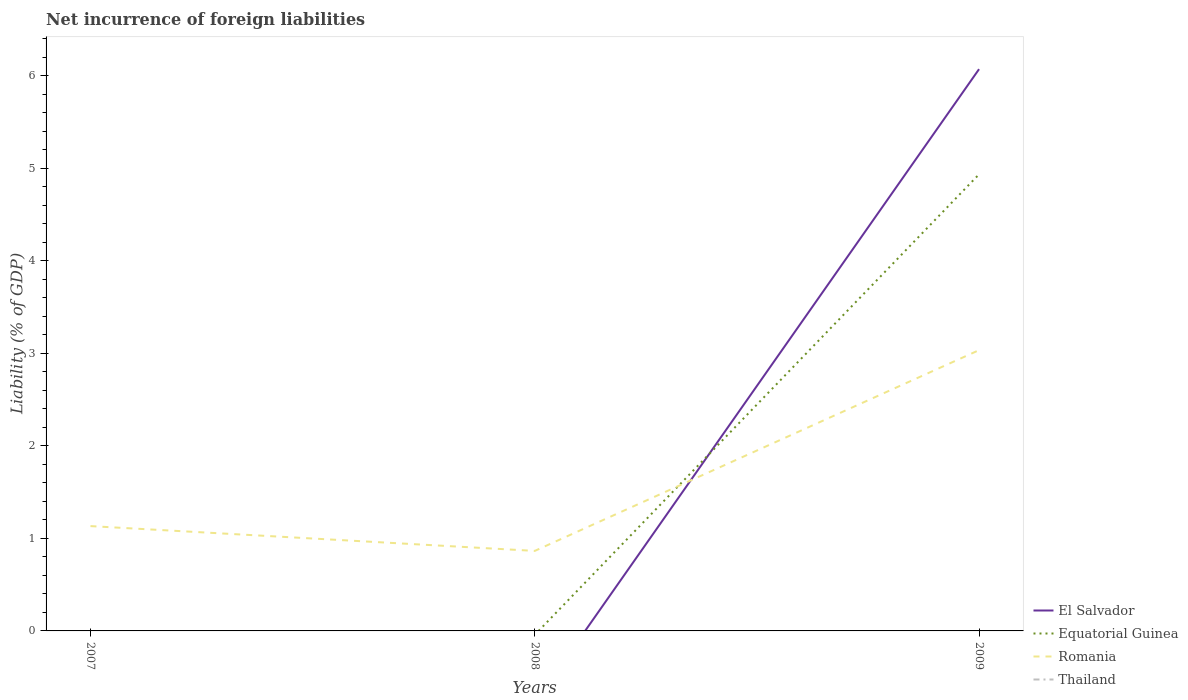How many different coloured lines are there?
Your answer should be compact. 3. Does the line corresponding to Equatorial Guinea intersect with the line corresponding to Thailand?
Offer a terse response. No. Across all years, what is the maximum net incurrence of foreign liabilities in El Salvador?
Your response must be concise. 0. What is the total net incurrence of foreign liabilities in Romania in the graph?
Your answer should be compact. 0.27. What is the difference between the highest and the second highest net incurrence of foreign liabilities in El Salvador?
Make the answer very short. 6.07. Is the net incurrence of foreign liabilities in Thailand strictly greater than the net incurrence of foreign liabilities in Equatorial Guinea over the years?
Provide a short and direct response. Yes. How many years are there in the graph?
Provide a succinct answer. 3. Are the values on the major ticks of Y-axis written in scientific E-notation?
Offer a very short reply. No. How many legend labels are there?
Keep it short and to the point. 4. How are the legend labels stacked?
Your response must be concise. Vertical. What is the title of the graph?
Offer a terse response. Net incurrence of foreign liabilities. Does "Grenada" appear as one of the legend labels in the graph?
Offer a terse response. No. What is the label or title of the Y-axis?
Your answer should be very brief. Liability (% of GDP). What is the Liability (% of GDP) of El Salvador in 2007?
Make the answer very short. 0. What is the Liability (% of GDP) in Equatorial Guinea in 2007?
Provide a short and direct response. 0. What is the Liability (% of GDP) of Romania in 2007?
Provide a succinct answer. 1.13. What is the Liability (% of GDP) of Romania in 2008?
Your answer should be compact. 0.87. What is the Liability (% of GDP) of El Salvador in 2009?
Make the answer very short. 6.07. What is the Liability (% of GDP) of Equatorial Guinea in 2009?
Ensure brevity in your answer.  4.94. What is the Liability (% of GDP) of Romania in 2009?
Offer a terse response. 3.04. What is the Liability (% of GDP) in Thailand in 2009?
Your answer should be compact. 0. Across all years, what is the maximum Liability (% of GDP) of El Salvador?
Make the answer very short. 6.07. Across all years, what is the maximum Liability (% of GDP) in Equatorial Guinea?
Make the answer very short. 4.94. Across all years, what is the maximum Liability (% of GDP) of Romania?
Offer a terse response. 3.04. Across all years, what is the minimum Liability (% of GDP) of El Salvador?
Your answer should be compact. 0. Across all years, what is the minimum Liability (% of GDP) in Equatorial Guinea?
Provide a short and direct response. 0. Across all years, what is the minimum Liability (% of GDP) in Romania?
Keep it short and to the point. 0.87. What is the total Liability (% of GDP) of El Salvador in the graph?
Provide a short and direct response. 6.07. What is the total Liability (% of GDP) of Equatorial Guinea in the graph?
Make the answer very short. 4.94. What is the total Liability (% of GDP) of Romania in the graph?
Offer a very short reply. 5.03. What is the total Liability (% of GDP) in Thailand in the graph?
Offer a very short reply. 0. What is the difference between the Liability (% of GDP) in Romania in 2007 and that in 2008?
Give a very brief answer. 0.27. What is the difference between the Liability (% of GDP) in Romania in 2007 and that in 2009?
Your response must be concise. -1.9. What is the difference between the Liability (% of GDP) of Romania in 2008 and that in 2009?
Your answer should be compact. -2.17. What is the average Liability (% of GDP) of El Salvador per year?
Keep it short and to the point. 2.02. What is the average Liability (% of GDP) of Equatorial Guinea per year?
Provide a short and direct response. 1.65. What is the average Liability (% of GDP) in Romania per year?
Offer a very short reply. 1.68. In the year 2009, what is the difference between the Liability (% of GDP) in El Salvador and Liability (% of GDP) in Equatorial Guinea?
Keep it short and to the point. 1.14. In the year 2009, what is the difference between the Liability (% of GDP) of El Salvador and Liability (% of GDP) of Romania?
Provide a short and direct response. 3.04. In the year 2009, what is the difference between the Liability (% of GDP) of Equatorial Guinea and Liability (% of GDP) of Romania?
Your response must be concise. 1.9. What is the ratio of the Liability (% of GDP) in Romania in 2007 to that in 2008?
Your answer should be very brief. 1.31. What is the ratio of the Liability (% of GDP) in Romania in 2007 to that in 2009?
Make the answer very short. 0.37. What is the ratio of the Liability (% of GDP) in Romania in 2008 to that in 2009?
Offer a terse response. 0.28. What is the difference between the highest and the second highest Liability (% of GDP) of Romania?
Give a very brief answer. 1.9. What is the difference between the highest and the lowest Liability (% of GDP) of El Salvador?
Your answer should be compact. 6.07. What is the difference between the highest and the lowest Liability (% of GDP) in Equatorial Guinea?
Give a very brief answer. 4.94. What is the difference between the highest and the lowest Liability (% of GDP) in Romania?
Your response must be concise. 2.17. 